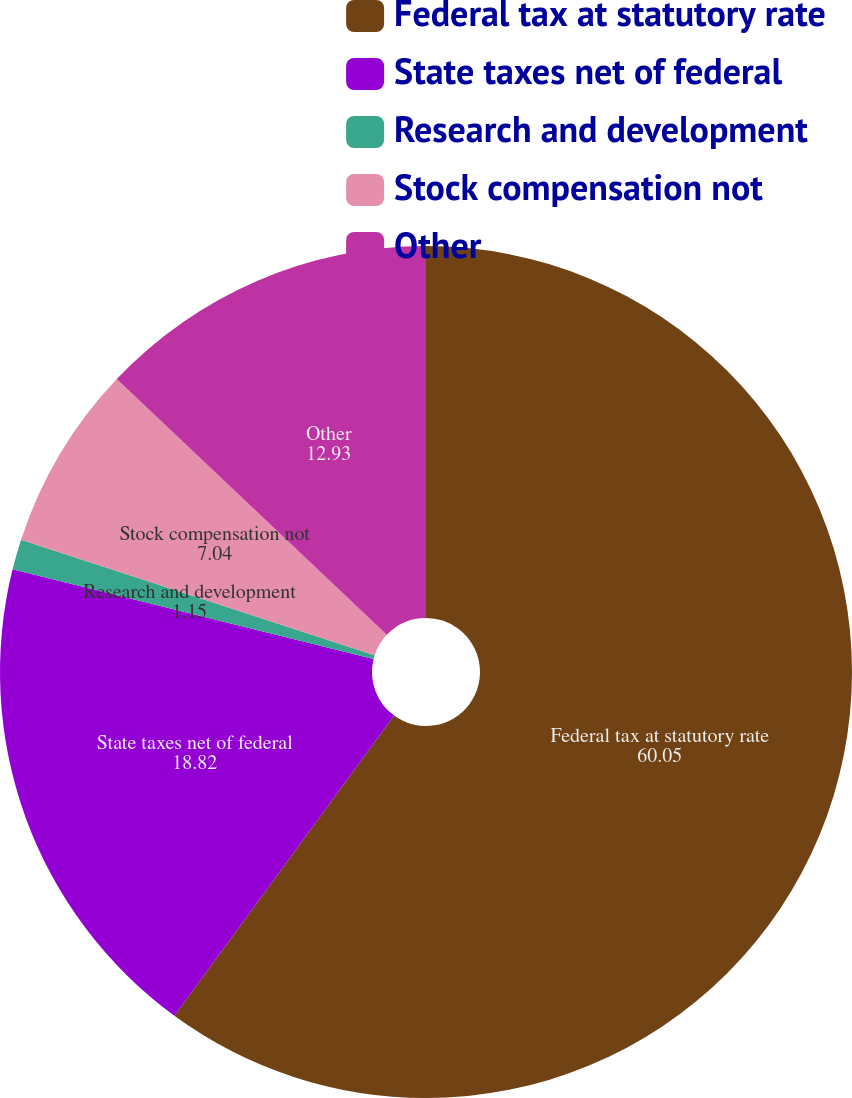Convert chart. <chart><loc_0><loc_0><loc_500><loc_500><pie_chart><fcel>Federal tax at statutory rate<fcel>State taxes net of federal<fcel>Research and development<fcel>Stock compensation not<fcel>Other<nl><fcel>60.05%<fcel>18.82%<fcel>1.15%<fcel>7.04%<fcel>12.93%<nl></chart> 